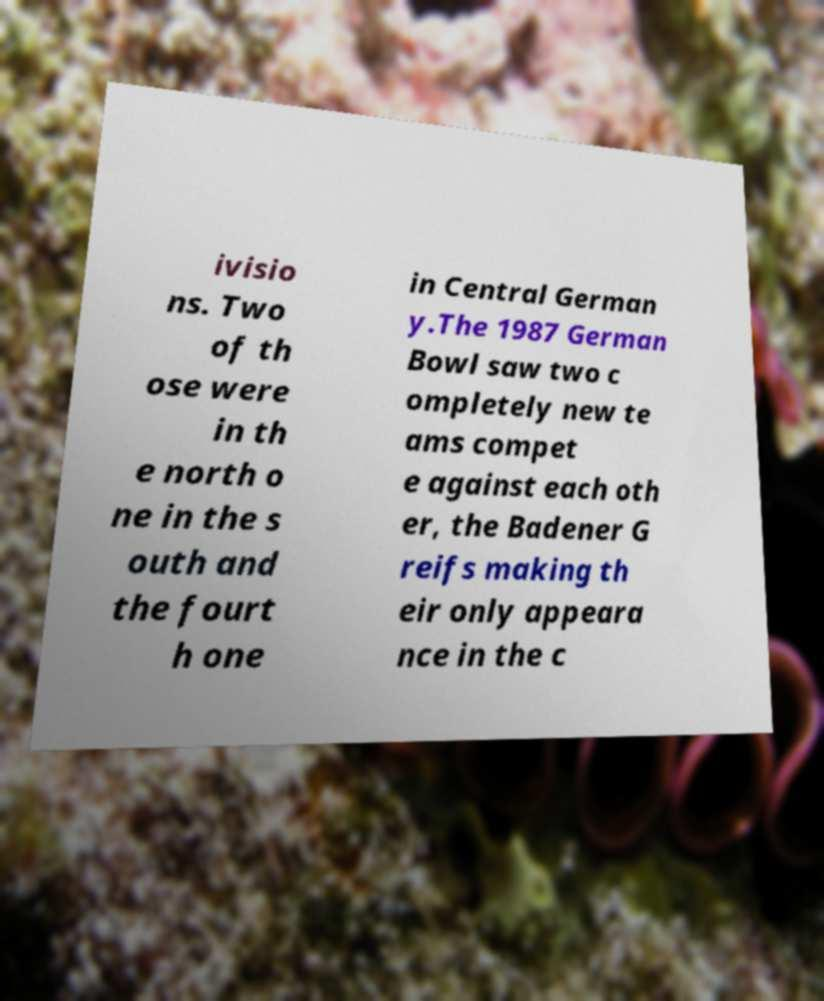Please identify and transcribe the text found in this image. ivisio ns. Two of th ose were in th e north o ne in the s outh and the fourt h one in Central German y.The 1987 German Bowl saw two c ompletely new te ams compet e against each oth er, the Badener G reifs making th eir only appeara nce in the c 